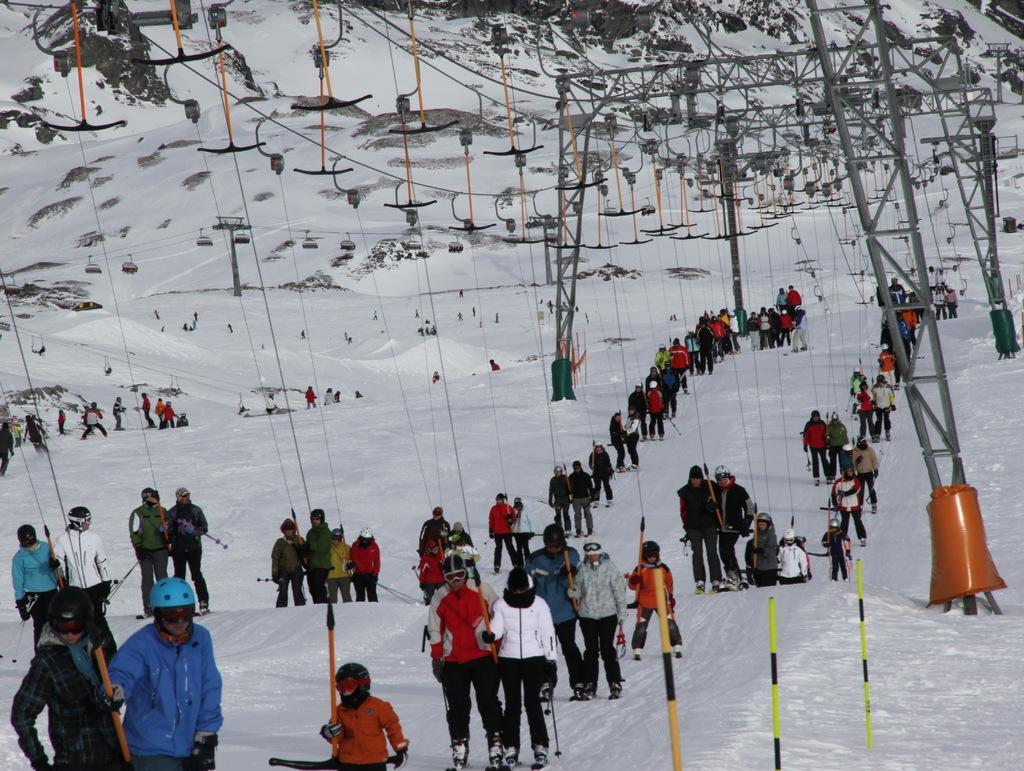How would you summarize this image in a sentence or two? Few people are skiing in the snow, these are the cables in the top side of an image. 